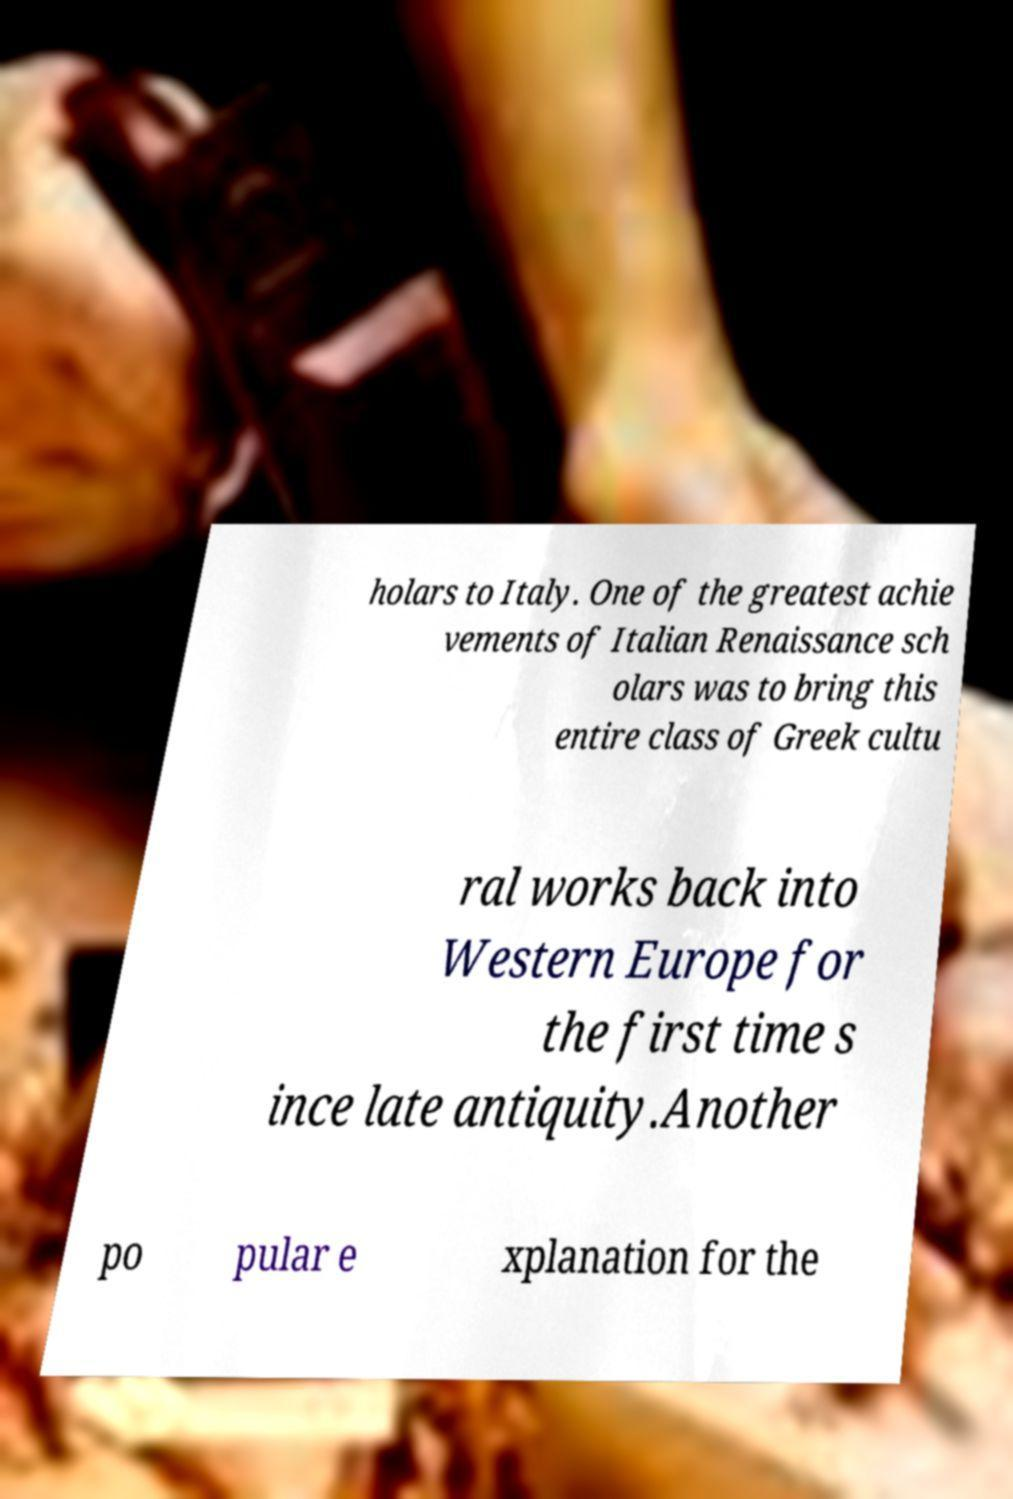There's text embedded in this image that I need extracted. Can you transcribe it verbatim? holars to Italy. One of the greatest achie vements of Italian Renaissance sch olars was to bring this entire class of Greek cultu ral works back into Western Europe for the first time s ince late antiquity.Another po pular e xplanation for the 